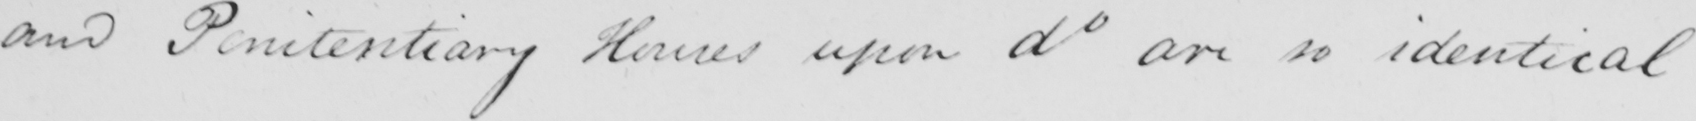Please transcribe the handwritten text in this image. and Penitentiary Houses upon do are so identical 